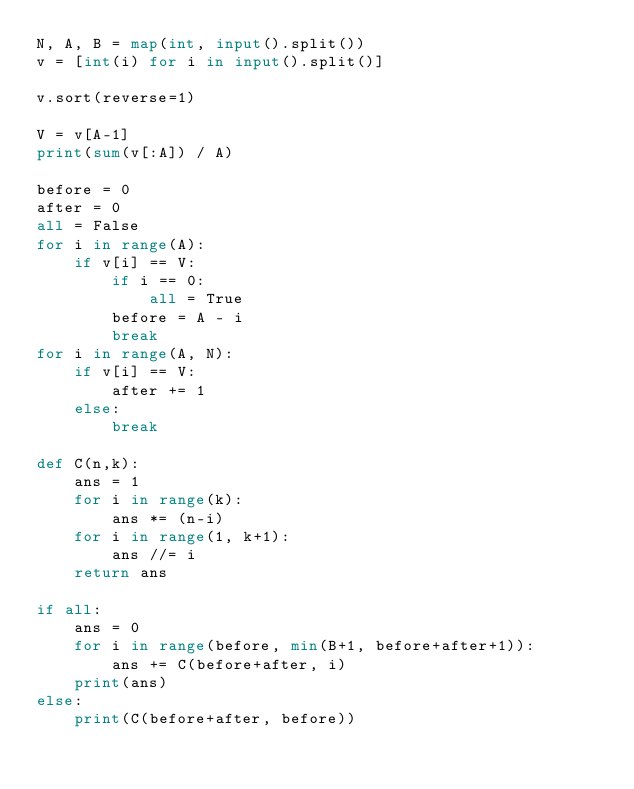Convert code to text. <code><loc_0><loc_0><loc_500><loc_500><_Python_>N, A, B = map(int, input().split())
v = [int(i) for i in input().split()]

v.sort(reverse=1)

V = v[A-1]
print(sum(v[:A]) / A)

before = 0
after = 0
all = False
for i in range(A):
    if v[i] == V:
        if i == 0:
            all = True
        before = A - i
        break
for i in range(A, N):
    if v[i] == V:
        after += 1
    else:
        break

def C(n,k):
    ans = 1
    for i in range(k):
        ans *= (n-i)
    for i in range(1, k+1):
        ans //= i
    return ans

if all:
    ans = 0
    for i in range(before, min(B+1, before+after+1)):
        ans += C(before+after, i)
    print(ans)
else:
    print(C(before+after, before))</code> 